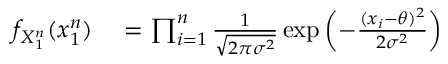<formula> <loc_0><loc_0><loc_500><loc_500>\begin{array} { r l r l } { f _ { X _ { 1 } ^ { n } } ( x _ { 1 } ^ { n } ) } & = \prod _ { i = 1 } ^ { n } { \frac { 1 } { \sqrt { 2 \pi \sigma ^ { 2 } } } } \exp \left ( - { \frac { ( x _ { i } - \theta ) ^ { 2 } } { 2 \sigma ^ { 2 } } } \right ) } \end{array}</formula> 